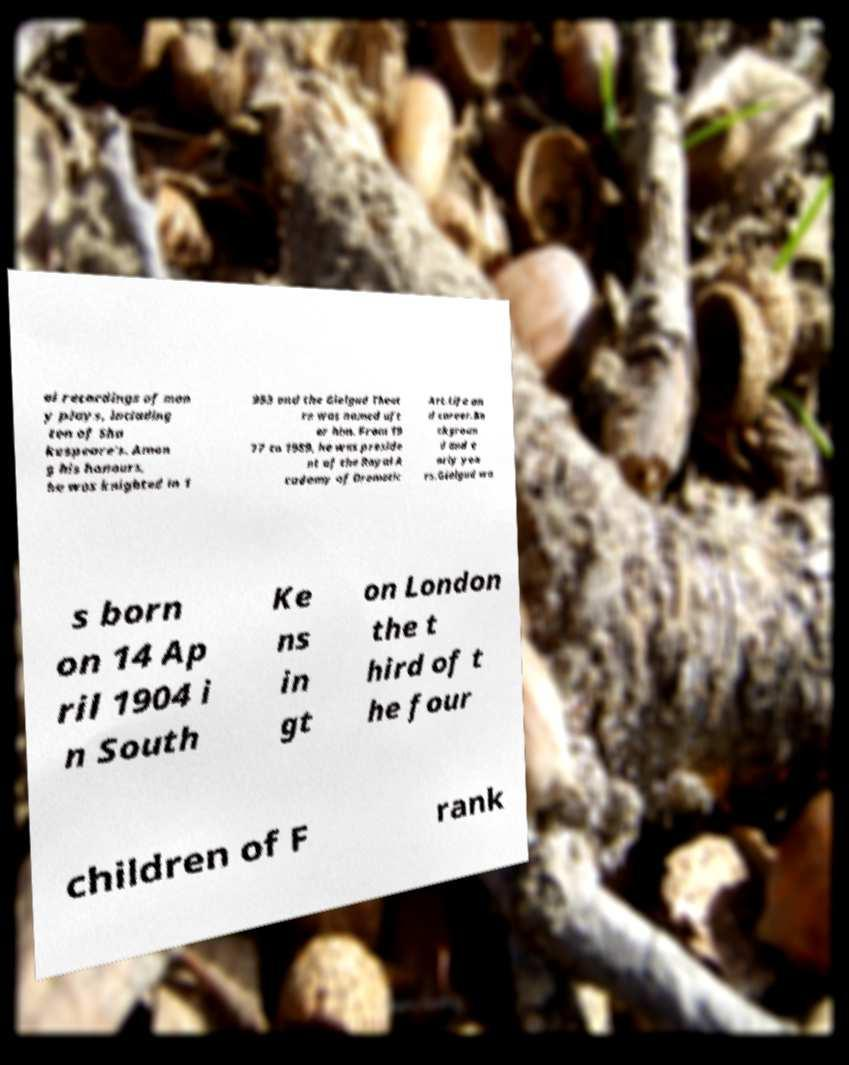Could you assist in decoding the text presented in this image and type it out clearly? al recordings of man y plays, including ten of Sha kespeare's. Amon g his honours, he was knighted in 1 953 and the Gielgud Theat re was named aft er him. From 19 77 to 1989, he was preside nt of the Royal A cademy of Dramatic Art.Life an d career.Ba ckgroun d and e arly yea rs.Gielgud wa s born on 14 Ap ril 1904 i n South Ke ns in gt on London the t hird of t he four children of F rank 